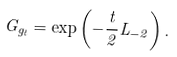Convert formula to latex. <formula><loc_0><loc_0><loc_500><loc_500>G _ { g _ { t } } = \exp \left ( - \frac { t } { 2 } L _ { - 2 } \right ) .</formula> 